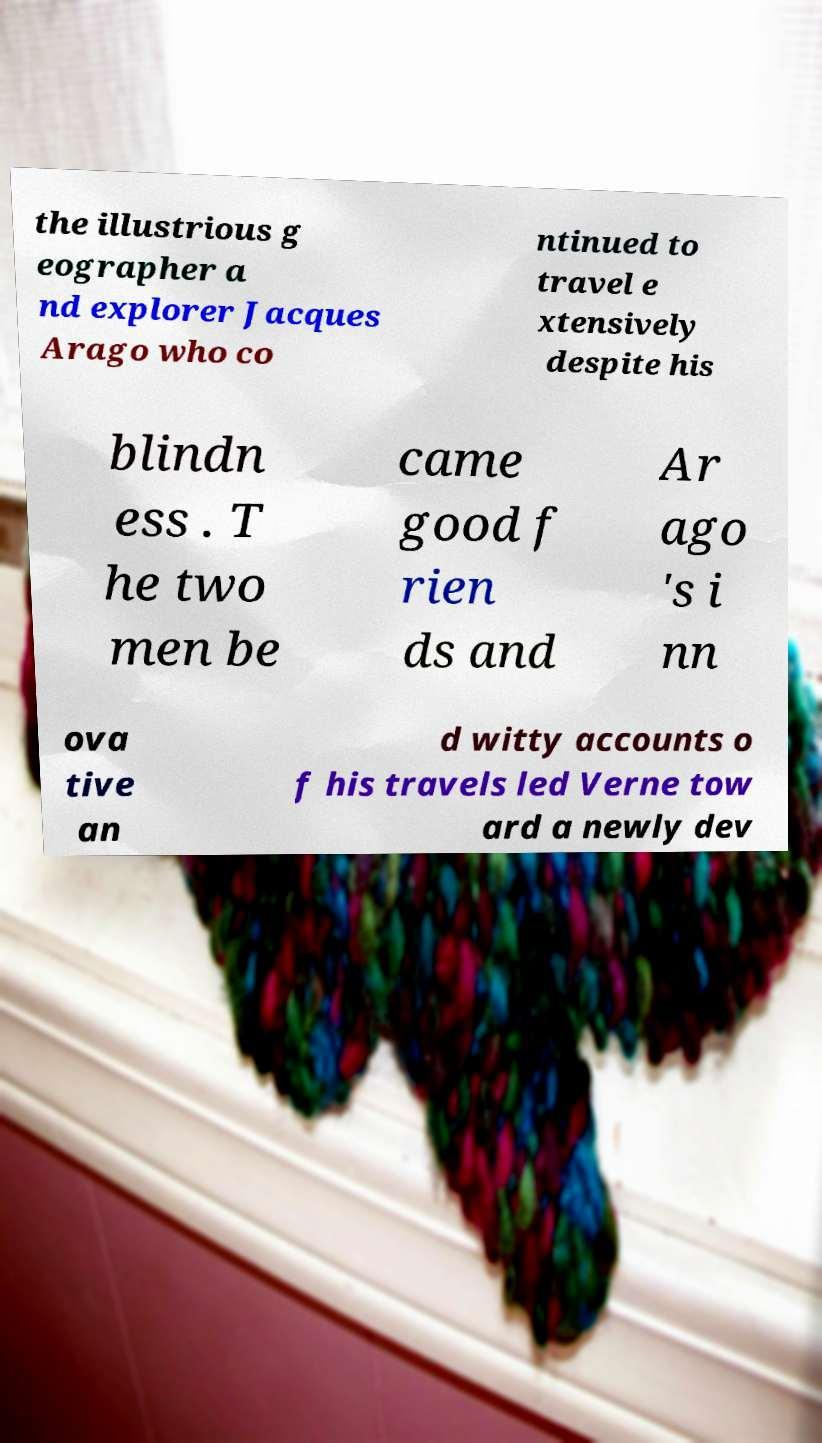There's text embedded in this image that I need extracted. Can you transcribe it verbatim? the illustrious g eographer a nd explorer Jacques Arago who co ntinued to travel e xtensively despite his blindn ess . T he two men be came good f rien ds and Ar ago 's i nn ova tive an d witty accounts o f his travels led Verne tow ard a newly dev 